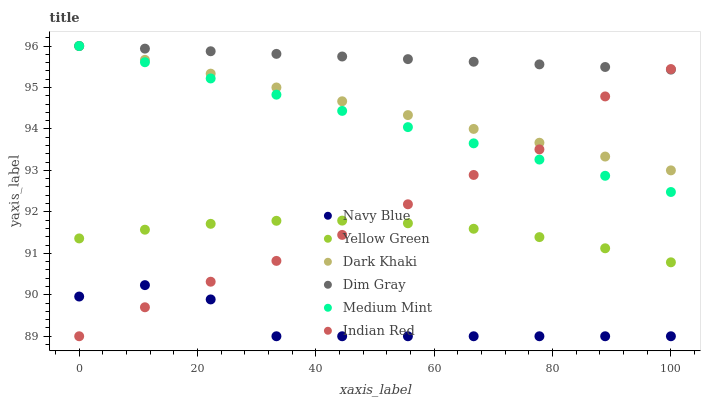Does Navy Blue have the minimum area under the curve?
Answer yes or no. Yes. Does Dim Gray have the maximum area under the curve?
Answer yes or no. Yes. Does Yellow Green have the minimum area under the curve?
Answer yes or no. No. Does Yellow Green have the maximum area under the curve?
Answer yes or no. No. Is Dim Gray the smoothest?
Answer yes or no. Yes. Is Navy Blue the roughest?
Answer yes or no. Yes. Is Yellow Green the smoothest?
Answer yes or no. No. Is Yellow Green the roughest?
Answer yes or no. No. Does Navy Blue have the lowest value?
Answer yes or no. Yes. Does Yellow Green have the lowest value?
Answer yes or no. No. Does Dark Khaki have the highest value?
Answer yes or no. Yes. Does Yellow Green have the highest value?
Answer yes or no. No. Is Yellow Green less than Dark Khaki?
Answer yes or no. Yes. Is Medium Mint greater than Navy Blue?
Answer yes or no. Yes. Does Indian Red intersect Dark Khaki?
Answer yes or no. Yes. Is Indian Red less than Dark Khaki?
Answer yes or no. No. Is Indian Red greater than Dark Khaki?
Answer yes or no. No. Does Yellow Green intersect Dark Khaki?
Answer yes or no. No. 